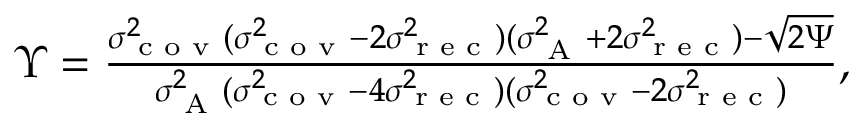Convert formula to latex. <formula><loc_0><loc_0><loc_500><loc_500>\begin{array} { r } { \Upsilon = \frac { \sigma _ { c o v } ^ { 2 } ( \sigma _ { c o v } ^ { 2 } - 2 \sigma _ { r e c } ^ { 2 } ) ( \sigma _ { A } ^ { 2 } + 2 \sigma _ { r e c } ^ { 2 } ) - \sqrt { 2 \Psi } } { \sigma _ { A } ^ { 2 } ( \sigma _ { c o v } ^ { 2 } - 4 \sigma _ { r e c } ^ { 2 } ) ( \sigma _ { c o v } ^ { 2 } - 2 \sigma _ { r e c } ^ { 2 } ) } , } \end{array}</formula> 